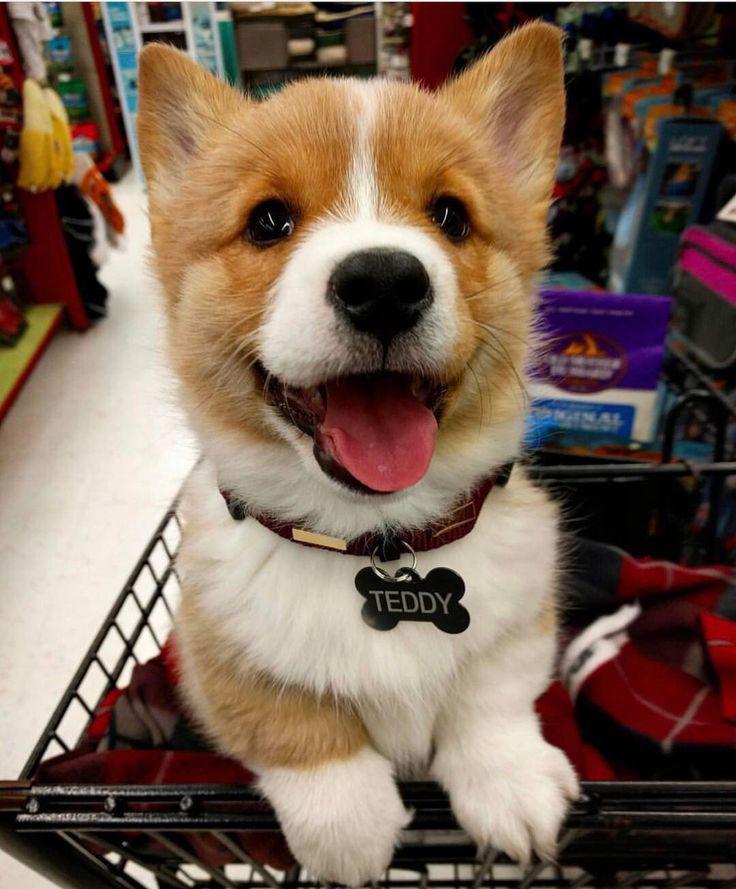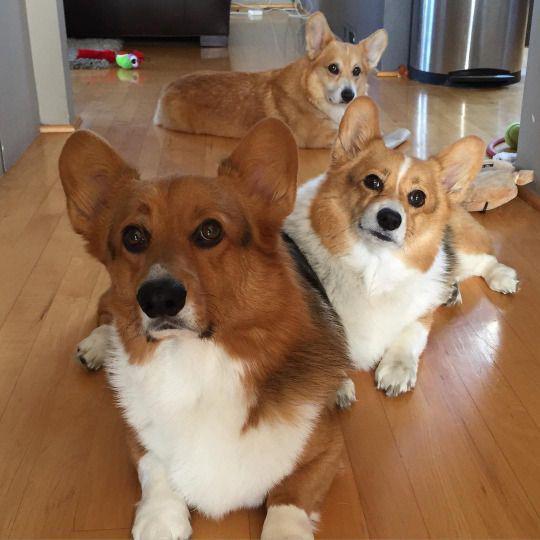The first image is the image on the left, the second image is the image on the right. Evaluate the accuracy of this statement regarding the images: "At least one Corgi is behind a container of food.". Is it true? Answer yes or no. No. The first image is the image on the left, the second image is the image on the right. For the images shown, is this caption "There us food in front of a single dog in at least one of the images." true? Answer yes or no. No. 